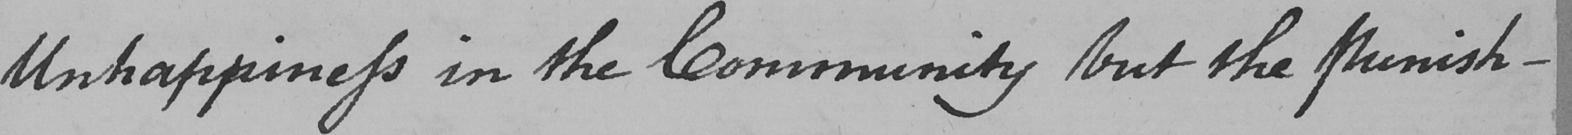Can you tell me what this handwritten text says? Unhappiness in the Community but the Punish- 